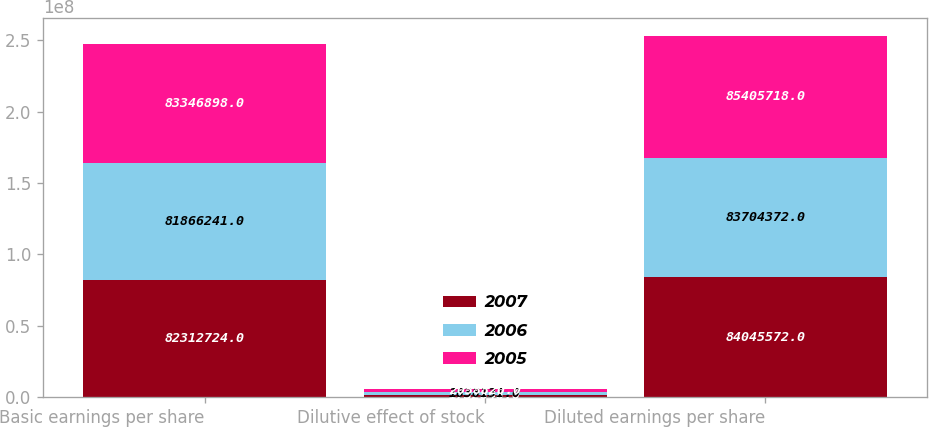<chart> <loc_0><loc_0><loc_500><loc_500><stacked_bar_chart><ecel><fcel>Basic earnings per share<fcel>Dilutive effect of stock<fcel>Diluted earnings per share<nl><fcel>2007<fcel>8.23127e+07<fcel>1.73285e+06<fcel>8.40456e+07<nl><fcel>2006<fcel>8.18662e+07<fcel>1.83813e+06<fcel>8.37044e+07<nl><fcel>2005<fcel>8.33469e+07<fcel>2.05882e+06<fcel>8.54057e+07<nl></chart> 